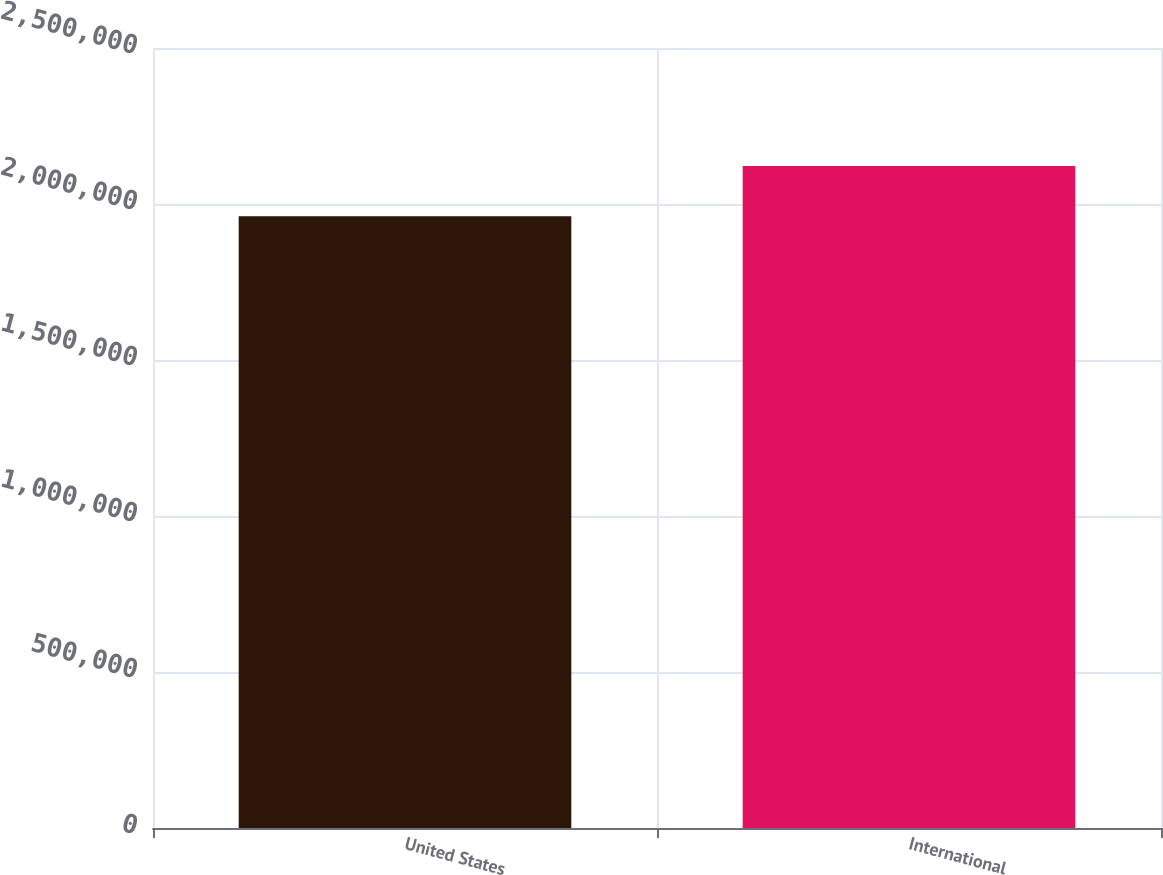Convert chart. <chart><loc_0><loc_0><loc_500><loc_500><bar_chart><fcel>United States<fcel>International<nl><fcel>1.96048e+06<fcel>2.12168e+06<nl></chart> 